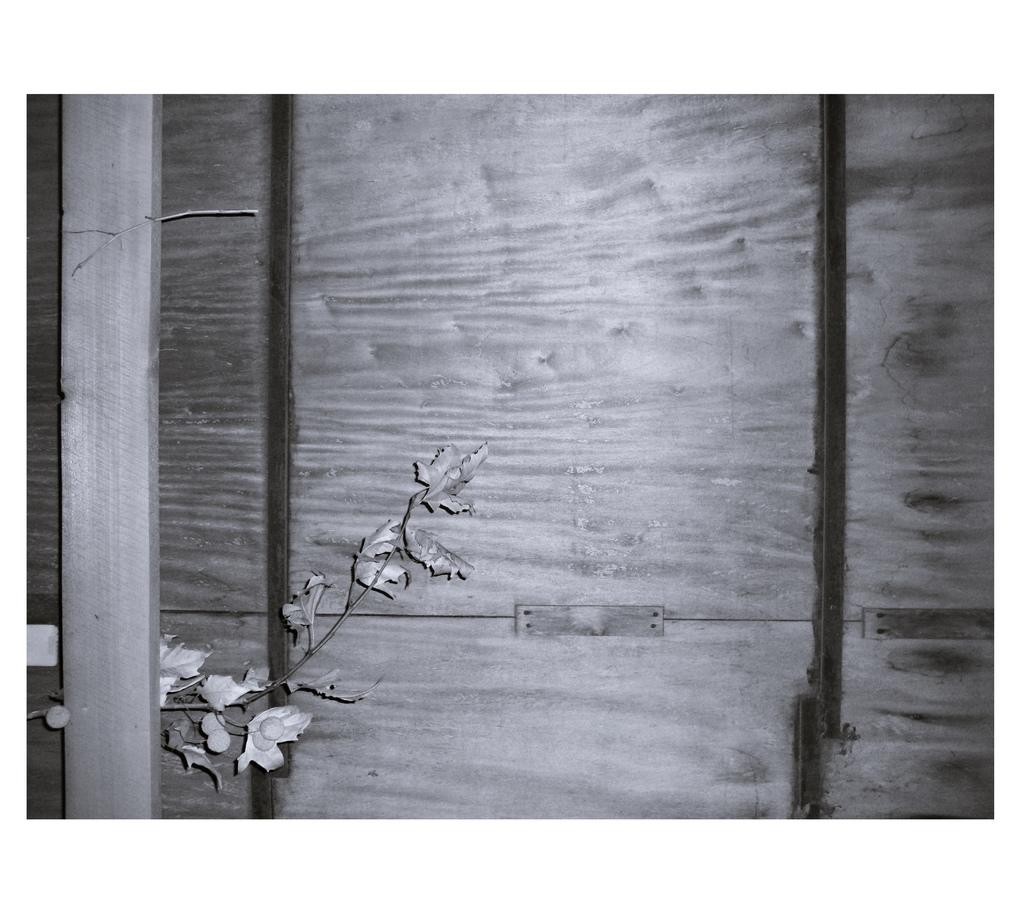What natural element is present in the image? There is a branch of a tree in the image. What structure can be seen on the left side of the image? There is a pole on the left side of the image. What type of man-made structure is visible in the background of the image? There is a wall in the background of the image. What type of grass is growing on the edge of the pole in the image? There is no grass present in the image, and the pole does not have an edge. 